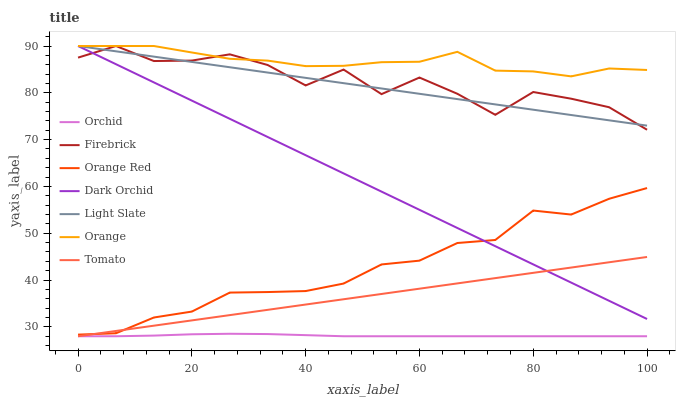Does Orchid have the minimum area under the curve?
Answer yes or no. Yes. Does Orange have the maximum area under the curve?
Answer yes or no. Yes. Does Light Slate have the minimum area under the curve?
Answer yes or no. No. Does Light Slate have the maximum area under the curve?
Answer yes or no. No. Is Tomato the smoothest?
Answer yes or no. Yes. Is Firebrick the roughest?
Answer yes or no. Yes. Is Light Slate the smoothest?
Answer yes or no. No. Is Light Slate the roughest?
Answer yes or no. No. Does Tomato have the lowest value?
Answer yes or no. Yes. Does Light Slate have the lowest value?
Answer yes or no. No. Does Orange have the highest value?
Answer yes or no. Yes. Does Orange Red have the highest value?
Answer yes or no. No. Is Orchid less than Light Slate?
Answer yes or no. Yes. Is Firebrick greater than Orchid?
Answer yes or no. Yes. Does Orange Red intersect Tomato?
Answer yes or no. Yes. Is Orange Red less than Tomato?
Answer yes or no. No. Is Orange Red greater than Tomato?
Answer yes or no. No. Does Orchid intersect Light Slate?
Answer yes or no. No. 